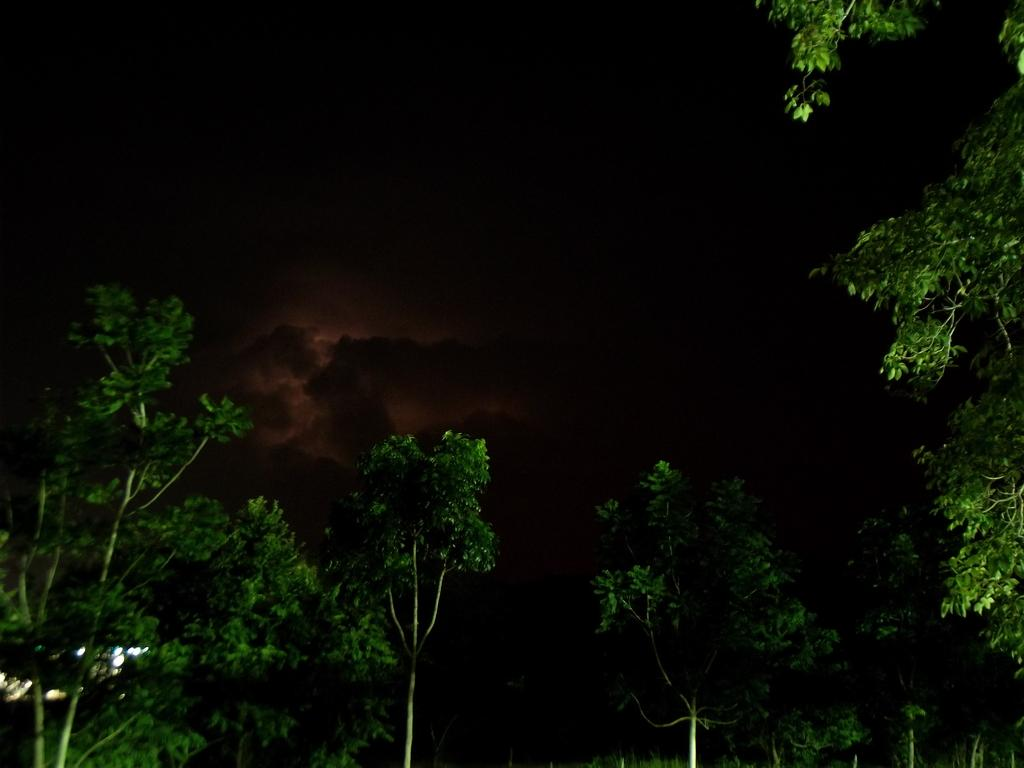What type of natural elements can be seen in the image? There are trees in the image. What artificial elements can be seen in the image? There are lights in the image. How would you describe the overall lighting in the image? The background of the image is dark. What type of notebook is being used by the partner in the image? There is no partner or notebook present in the image. What scent can be detected in the image? There is no mention of any scent in the image. 